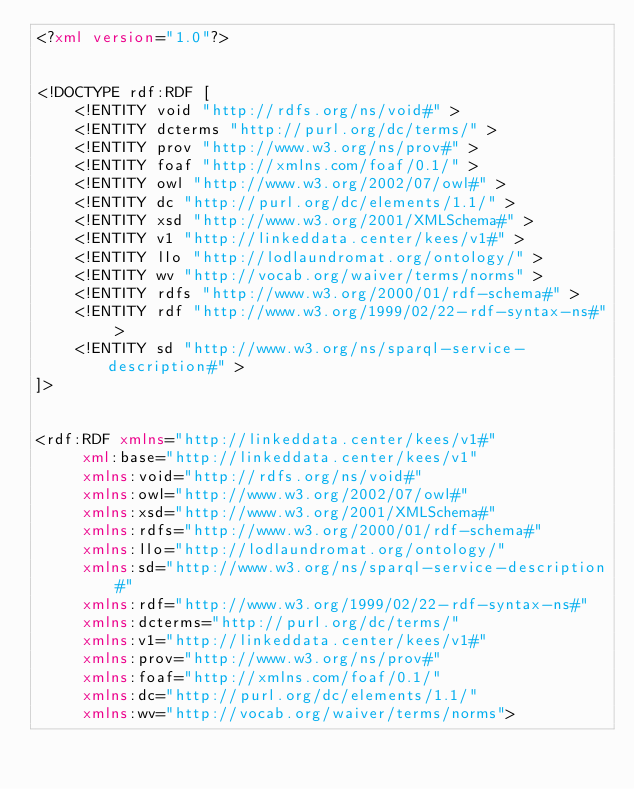Convert code to text. <code><loc_0><loc_0><loc_500><loc_500><_XML_><?xml version="1.0"?>


<!DOCTYPE rdf:RDF [
    <!ENTITY void "http://rdfs.org/ns/void#" >
    <!ENTITY dcterms "http://purl.org/dc/terms/" >
    <!ENTITY prov "http://www.w3.org/ns/prov#" >
    <!ENTITY foaf "http://xmlns.com/foaf/0.1/" >
    <!ENTITY owl "http://www.w3.org/2002/07/owl#" >
    <!ENTITY dc "http://purl.org/dc/elements/1.1/" >
    <!ENTITY xsd "http://www.w3.org/2001/XMLSchema#" >
    <!ENTITY v1 "http://linkeddata.center/kees/v1#" >
    <!ENTITY llo "http://lodlaundromat.org/ontology/" >
    <!ENTITY wv "http://vocab.org/waiver/terms/norms" >
    <!ENTITY rdfs "http://www.w3.org/2000/01/rdf-schema#" >
    <!ENTITY rdf "http://www.w3.org/1999/02/22-rdf-syntax-ns#" >
    <!ENTITY sd "http://www.w3.org/ns/sparql-service-description#" >
]>


<rdf:RDF xmlns="http://linkeddata.center/kees/v1#"
     xml:base="http://linkeddata.center/kees/v1"
     xmlns:void="http://rdfs.org/ns/void#"
     xmlns:owl="http://www.w3.org/2002/07/owl#"
     xmlns:xsd="http://www.w3.org/2001/XMLSchema#"
     xmlns:rdfs="http://www.w3.org/2000/01/rdf-schema#"
     xmlns:llo="http://lodlaundromat.org/ontology/"
     xmlns:sd="http://www.w3.org/ns/sparql-service-description#"
     xmlns:rdf="http://www.w3.org/1999/02/22-rdf-syntax-ns#"
     xmlns:dcterms="http://purl.org/dc/terms/"
     xmlns:v1="http://linkeddata.center/kees/v1#"
     xmlns:prov="http://www.w3.org/ns/prov#"
     xmlns:foaf="http://xmlns.com/foaf/0.1/"
     xmlns:dc="http://purl.org/dc/elements/1.1/"
     xmlns:wv="http://vocab.org/waiver/terms/norms"></code> 